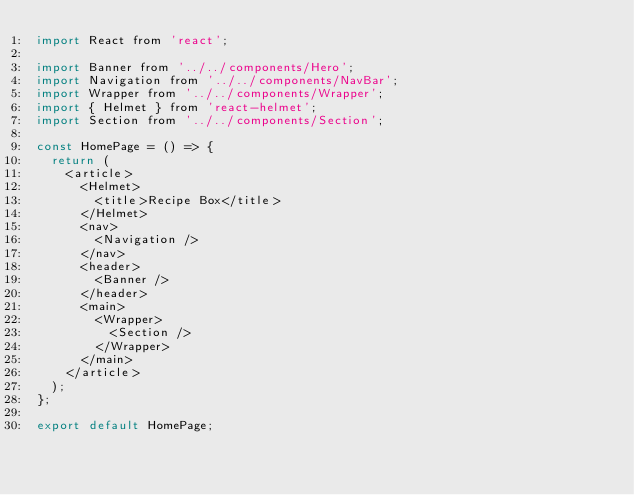Convert code to text. <code><loc_0><loc_0><loc_500><loc_500><_JavaScript_>import React from 'react';

import Banner from '../../components/Hero';
import Navigation from '../../components/NavBar';
import Wrapper from '../../components/Wrapper';
import { Helmet } from 'react-helmet';
import Section from '../../components/Section';

const HomePage = () => {
  return (
    <article>
      <Helmet>
        <title>Recipe Box</title>
      </Helmet>
      <nav>
        <Navigation />
      </nav>
      <header>
        <Banner />
      </header>
      <main>
        <Wrapper>
          <Section />
        </Wrapper>
      </main>
    </article>
  );
};

export default HomePage;
</code> 